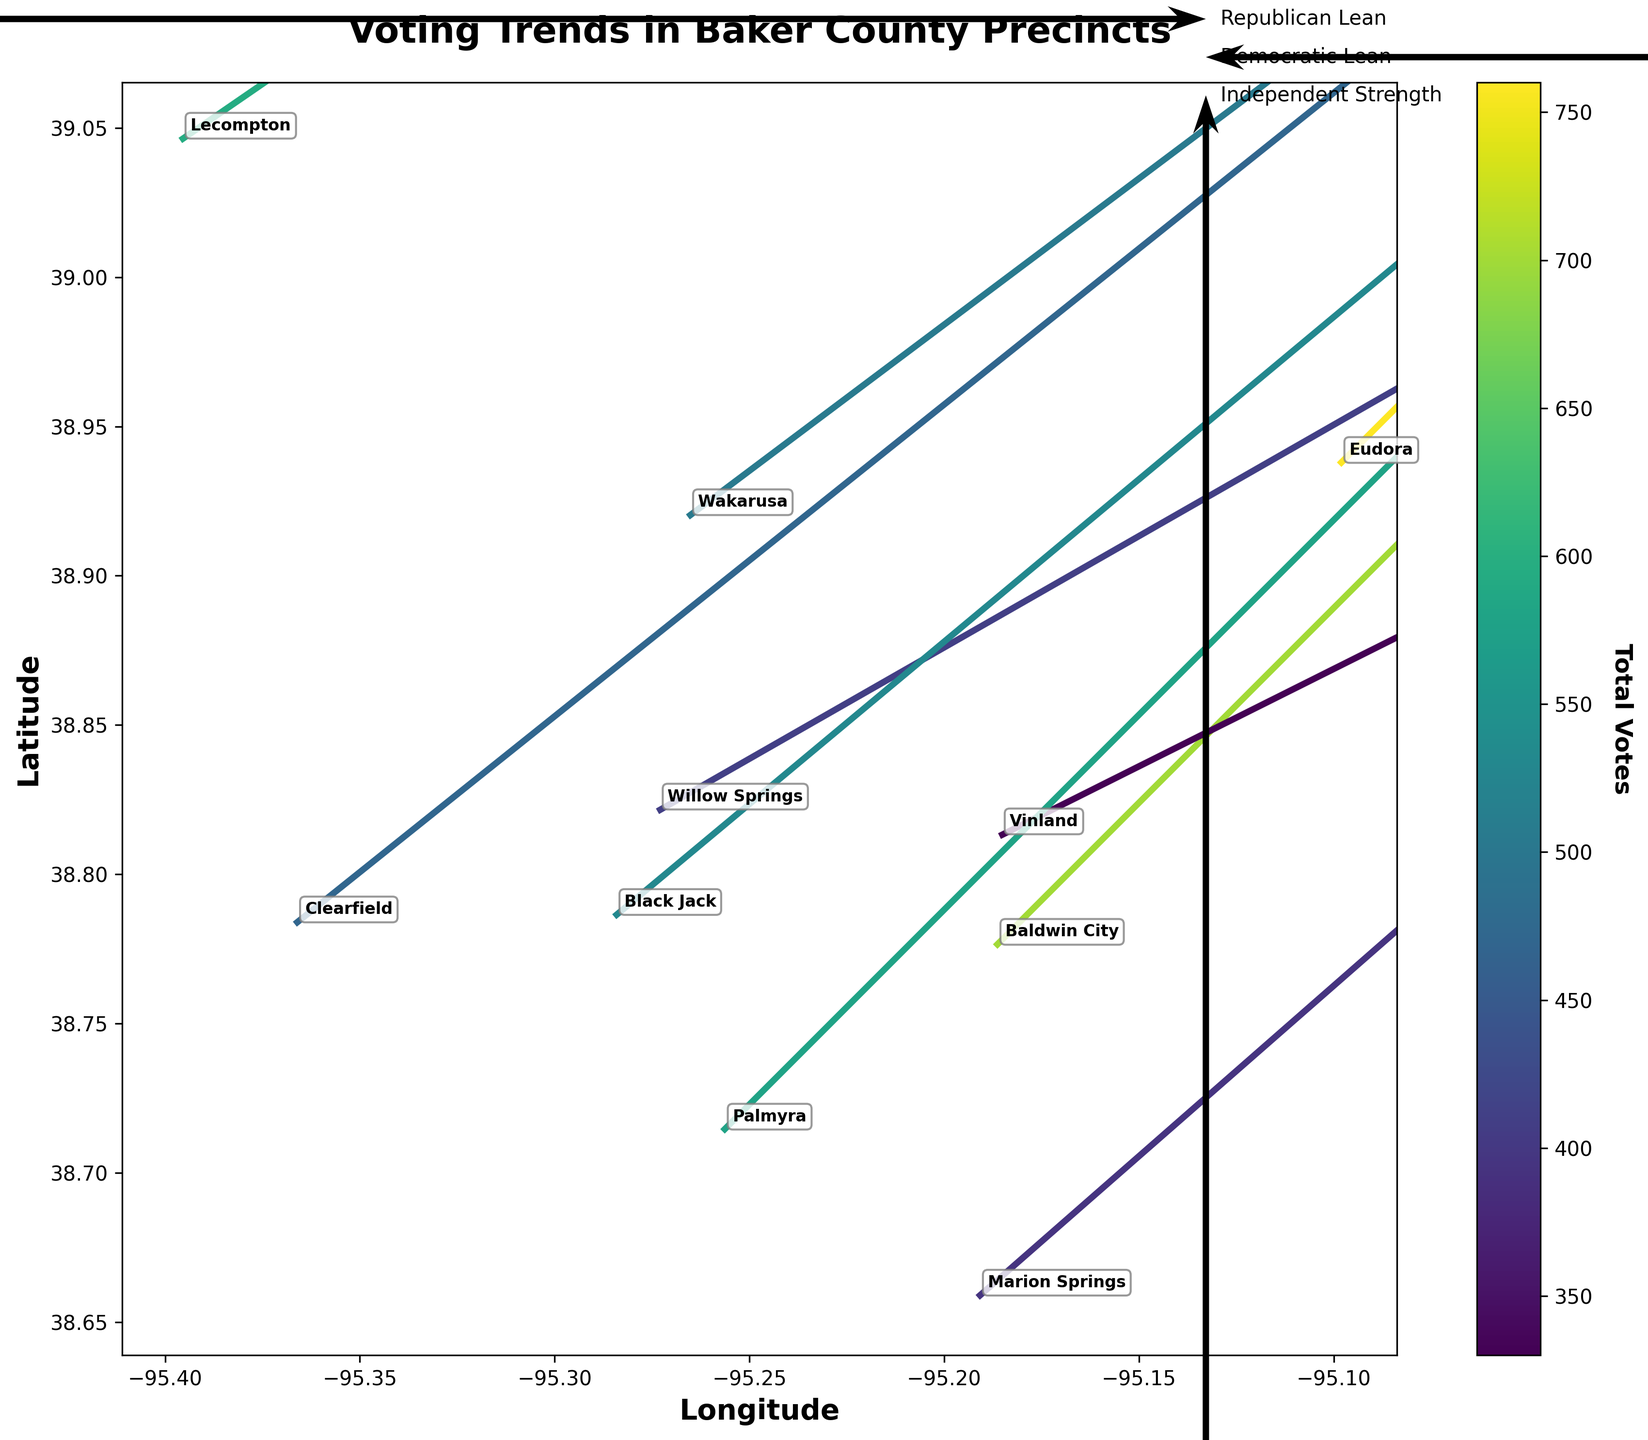What is the title of the plot? The title is usually displayed at the top of the plot. If you look at the plot, you will see the text "Voting Trends in Baker County Precincts" in bold.
Answer: Voting Trends in Baker County Precincts Which axis represents the latitude? The latitude is represented on the vertical axis, which is labeled "Latitude" on the plot.
Answer: Vertical axis How many precincts are displayed in the plot? The number of precincts can be determined by counting the data points annotated on the plot. There are 10 precincts listed.
Answer: 10 What do the colors in the plot represent? The color represents the total number of votes in each precinct. This is indicated by the color bar on the side of the plot labeled "Total Votes."
Answer: Total votes Which precinct has the highest total votes? By referring to the color bar, the precinct with the darkest color indicates the highest total votes. It's "Eudora."
Answer: Eudora In which direction do the vectors lean for Republican votes? The vectors lean horizontally towards the right for Republican votes as the u-component (rep - dem) / total_votes will be positive when Republican votes are greater.
Answer: Right Which precinct shows the strongest independent voting strength? Independent strength is depicted by the v-component. The longest vector extending more vertically (ind component) is observed in "Eudora."
Answer: Eudora Compare the voting trends between "Lecompton" and "Baldwin City." To compare, we observe the directions of the vectors in both precincts. "Lecompton" leans more right indicating more Republican votes, while "Baldwin City" also leans right but might be lesser than "Lecompton." We also compare color intensity for total votes.
Answer: Lecompton more Republican Which regions tend to vote more independent? The strength of independent votes is indicated by the vertical component of the vectors. Regions with longer vertical components like "Eudora" and "Marion Springs" tend to vote more independent.
Answer: Eudora and Marion Springs Are there any precincts with a Democratic leaning? Democratic leaning would be represented by vectors pointing to the left. Observing the plot, there are no clear leftward vectors; hence, no precincts with Democratic leaning.
Answer: No 